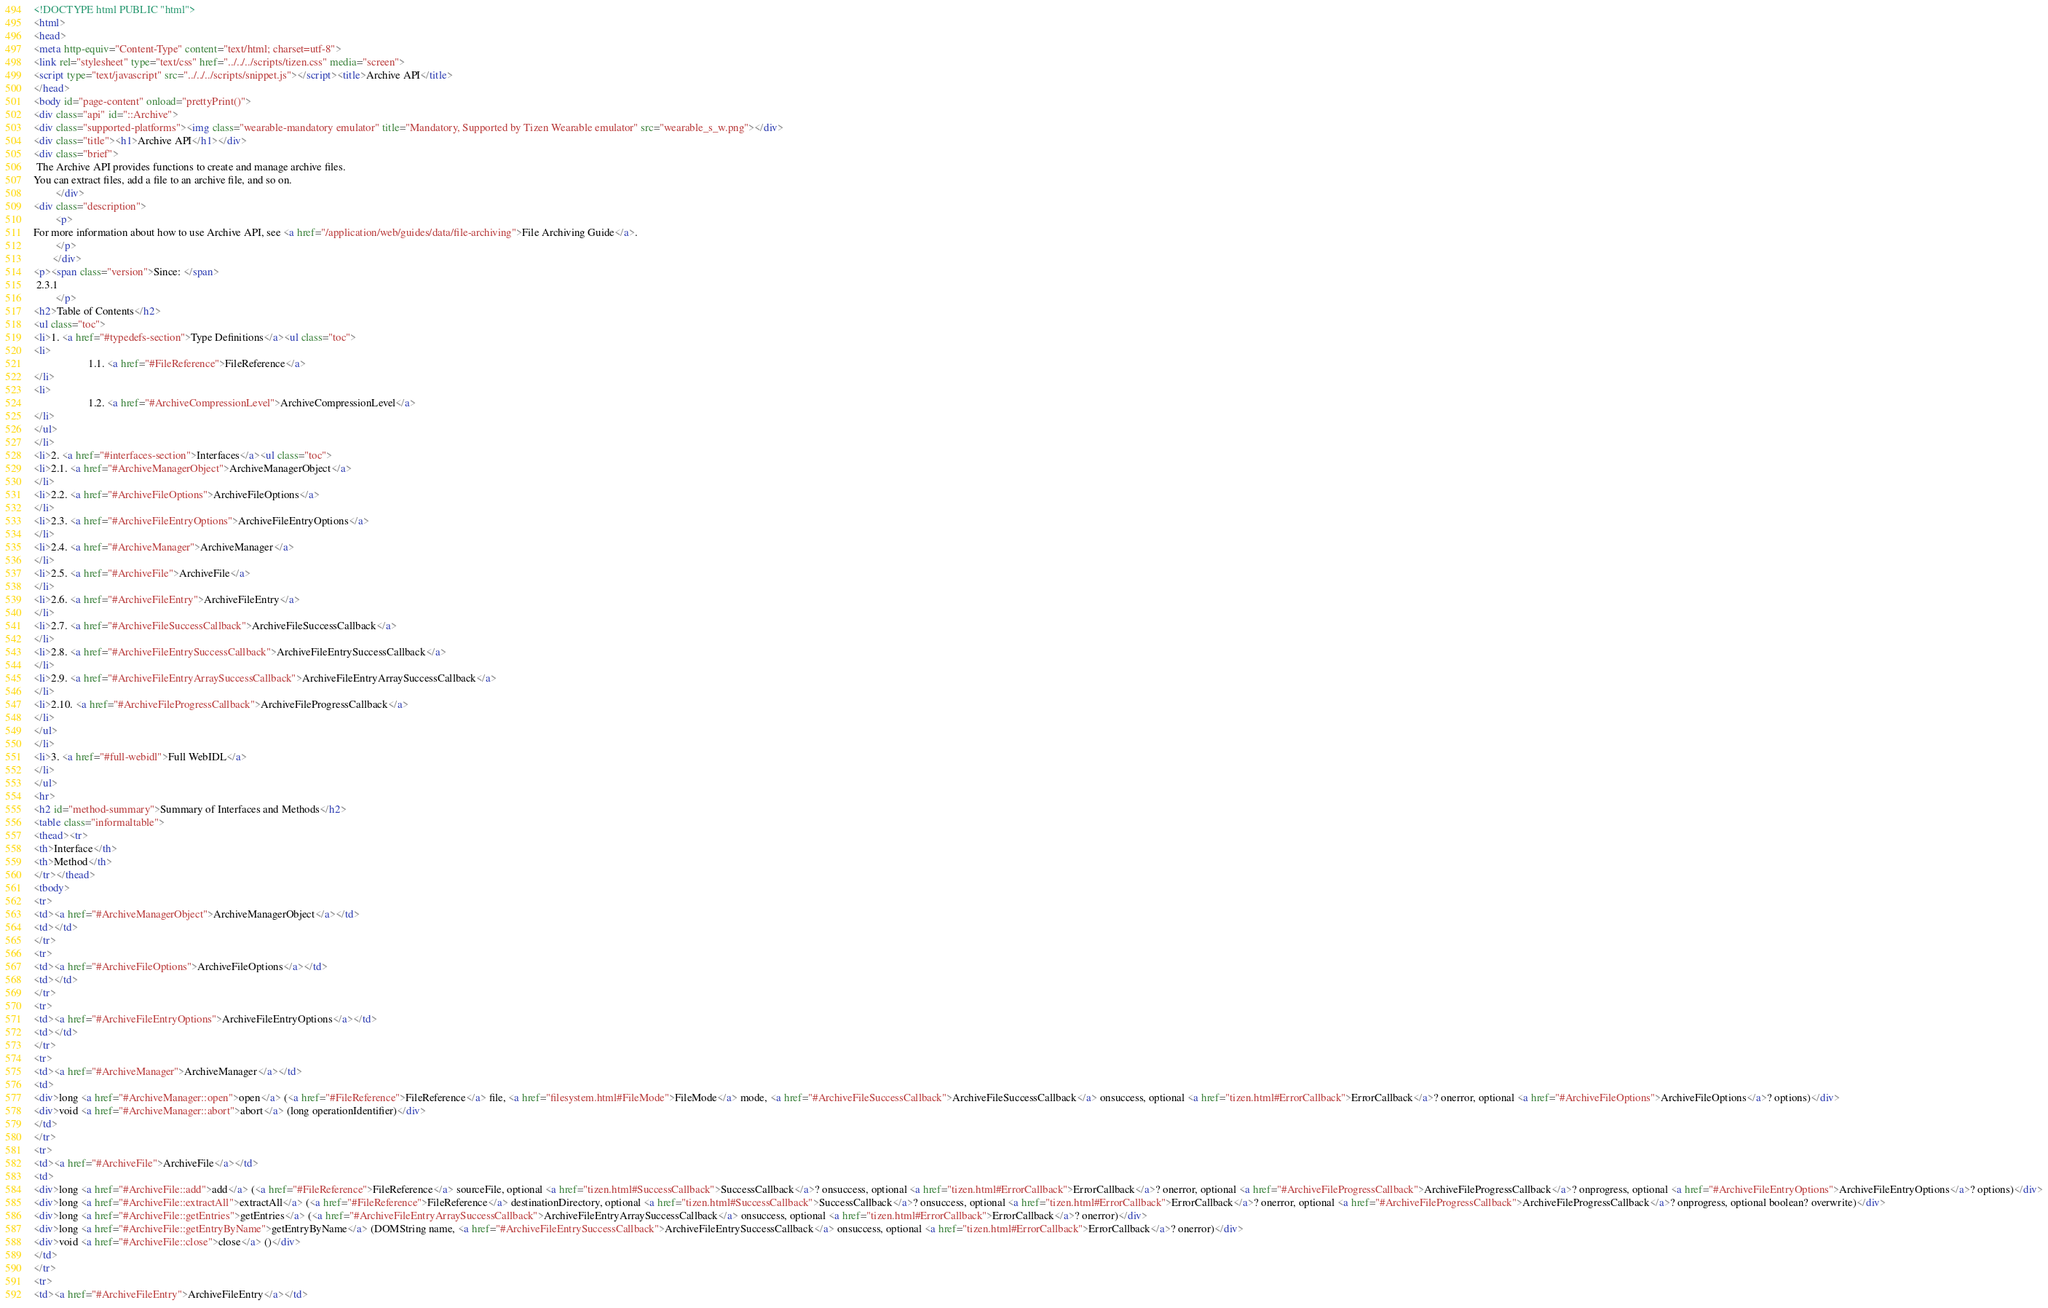<code> <loc_0><loc_0><loc_500><loc_500><_HTML_><!DOCTYPE html PUBLIC "html">
<html>
<head>
<meta http-equiv="Content-Type" content="text/html; charset=utf-8">
<link rel="stylesheet" type="text/css" href="../../../scripts/tizen.css" media="screen">
<script type="text/javascript" src="../../../scripts/snippet.js"></script><title>Archive API</title>
</head>
<body id="page-content" onload="prettyPrint()">
<div class="api" id="::Archive">
<div class="supported-platforms"><img class="wearable-mandatory emulator" title="Mandatory, Supported by Tizen Wearable emulator" src="wearable_s_w.png"></div>
<div class="title"><h1>Archive API</h1></div>
<div class="brief">
 The Archive API provides functions to create and manage archive files.
You can extract files, add a file to an archive file, and so on.
        </div>
<div class="description">
        <p>
For more information about how to use Archive API, see <a href="/application/web/guides/data/file-archiving">File Archiving Guide</a>.
        </p>
       </div>
<p><span class="version">Since: </span>
 2.3.1
        </p>
<h2>Table of Contents</h2>
<ul class="toc">
<li>1. <a href="#typedefs-section">Type Definitions</a><ul class="toc">
<li>
                    1.1. <a href="#FileReference">FileReference</a>
</li>
<li>
                    1.2. <a href="#ArchiveCompressionLevel">ArchiveCompressionLevel</a>
</li>
</ul>
</li>
<li>2. <a href="#interfaces-section">Interfaces</a><ul class="toc">
<li>2.1. <a href="#ArchiveManagerObject">ArchiveManagerObject</a>
</li>
<li>2.2. <a href="#ArchiveFileOptions">ArchiveFileOptions</a>
</li>
<li>2.3. <a href="#ArchiveFileEntryOptions">ArchiveFileEntryOptions</a>
</li>
<li>2.4. <a href="#ArchiveManager">ArchiveManager</a>
</li>
<li>2.5. <a href="#ArchiveFile">ArchiveFile</a>
</li>
<li>2.6. <a href="#ArchiveFileEntry">ArchiveFileEntry</a>
</li>
<li>2.7. <a href="#ArchiveFileSuccessCallback">ArchiveFileSuccessCallback</a>
</li>
<li>2.8. <a href="#ArchiveFileEntrySuccessCallback">ArchiveFileEntrySuccessCallback</a>
</li>
<li>2.9. <a href="#ArchiveFileEntryArraySuccessCallback">ArchiveFileEntryArraySuccessCallback</a>
</li>
<li>2.10. <a href="#ArchiveFileProgressCallback">ArchiveFileProgressCallback</a>
</li>
</ul>
</li>
<li>3. <a href="#full-webidl">Full WebIDL</a>
</li>
</ul>
<hr>
<h2 id="method-summary">Summary of Interfaces and Methods</h2>
<table class="informaltable">
<thead><tr>
<th>Interface</th>
<th>Method</th>
</tr></thead>
<tbody>
<tr>
<td><a href="#ArchiveManagerObject">ArchiveManagerObject</a></td>
<td></td>
</tr>
<tr>
<td><a href="#ArchiveFileOptions">ArchiveFileOptions</a></td>
<td></td>
</tr>
<tr>
<td><a href="#ArchiveFileEntryOptions">ArchiveFileEntryOptions</a></td>
<td></td>
</tr>
<tr>
<td><a href="#ArchiveManager">ArchiveManager</a></td>
<td>
<div>long <a href="#ArchiveManager::open">open</a> (<a href="#FileReference">FileReference</a> file, <a href="filesystem.html#FileMode">FileMode</a> mode, <a href="#ArchiveFileSuccessCallback">ArchiveFileSuccessCallback</a> onsuccess, optional <a href="tizen.html#ErrorCallback">ErrorCallback</a>? onerror, optional <a href="#ArchiveFileOptions">ArchiveFileOptions</a>? options)</div>
<div>void <a href="#ArchiveManager::abort">abort</a> (long operationIdentifier)</div>
</td>
</tr>
<tr>
<td><a href="#ArchiveFile">ArchiveFile</a></td>
<td>
<div>long <a href="#ArchiveFile::add">add</a> (<a href="#FileReference">FileReference</a> sourceFile, optional <a href="tizen.html#SuccessCallback">SuccessCallback</a>? onsuccess, optional <a href="tizen.html#ErrorCallback">ErrorCallback</a>? onerror, optional <a href="#ArchiveFileProgressCallback">ArchiveFileProgressCallback</a>? onprogress, optional <a href="#ArchiveFileEntryOptions">ArchiveFileEntryOptions</a>? options)</div>
<div>long <a href="#ArchiveFile::extractAll">extractAll</a> (<a href="#FileReference">FileReference</a> destinationDirectory, optional <a href="tizen.html#SuccessCallback">SuccessCallback</a>? onsuccess, optional <a href="tizen.html#ErrorCallback">ErrorCallback</a>? onerror, optional <a href="#ArchiveFileProgressCallback">ArchiveFileProgressCallback</a>? onprogress, optional boolean? overwrite)</div>
<div>long <a href="#ArchiveFile::getEntries">getEntries</a> (<a href="#ArchiveFileEntryArraySuccessCallback">ArchiveFileEntryArraySuccessCallback</a> onsuccess, optional <a href="tizen.html#ErrorCallback">ErrorCallback</a>? onerror)</div>
<div>long <a href="#ArchiveFile::getEntryByName">getEntryByName</a> (DOMString name, <a href="#ArchiveFileEntrySuccessCallback">ArchiveFileEntrySuccessCallback</a> onsuccess, optional <a href="tizen.html#ErrorCallback">ErrorCallback</a>? onerror)</div>
<div>void <a href="#ArchiveFile::close">close</a> ()</div>
</td>
</tr>
<tr>
<td><a href="#ArchiveFileEntry">ArchiveFileEntry</a></td></code> 